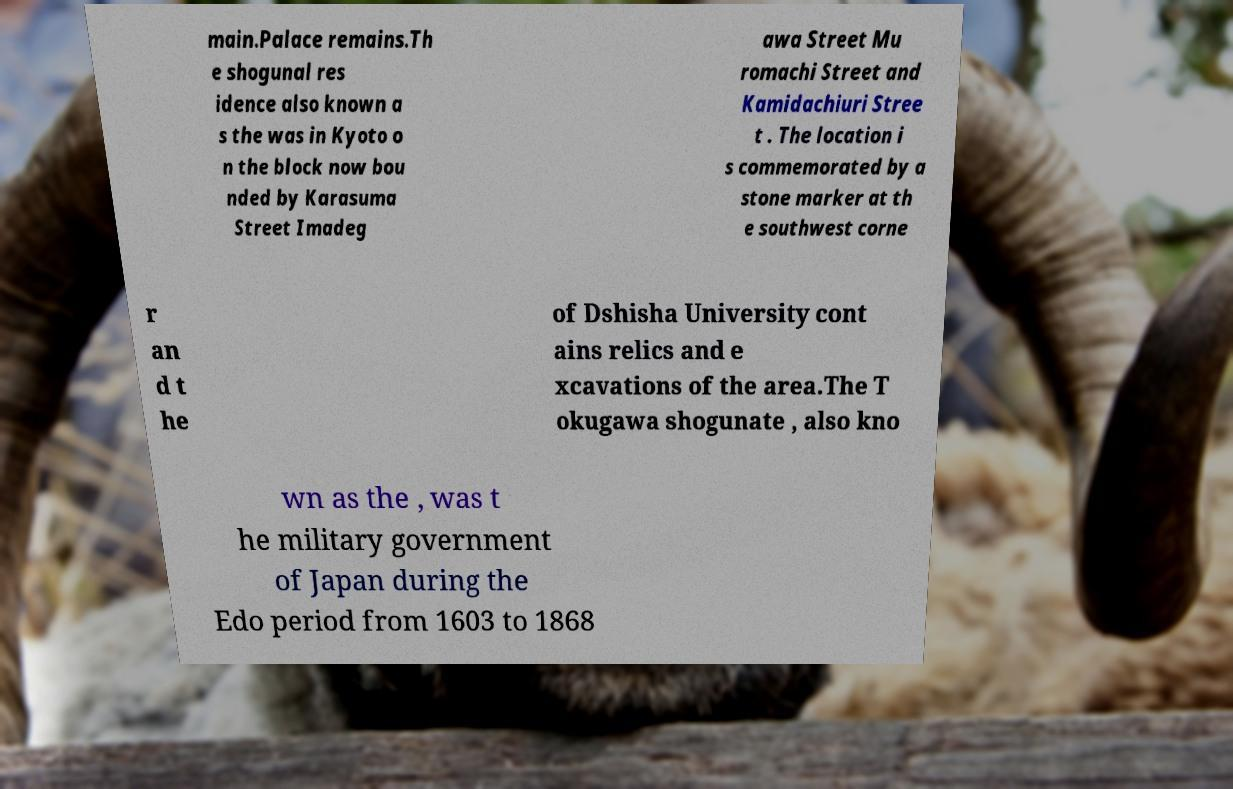There's text embedded in this image that I need extracted. Can you transcribe it verbatim? main.Palace remains.Th e shogunal res idence also known a s the was in Kyoto o n the block now bou nded by Karasuma Street Imadeg awa Street Mu romachi Street and Kamidachiuri Stree t . The location i s commemorated by a stone marker at th e southwest corne r an d t he of Dshisha University cont ains relics and e xcavations of the area.The T okugawa shogunate , also kno wn as the , was t he military government of Japan during the Edo period from 1603 to 1868 